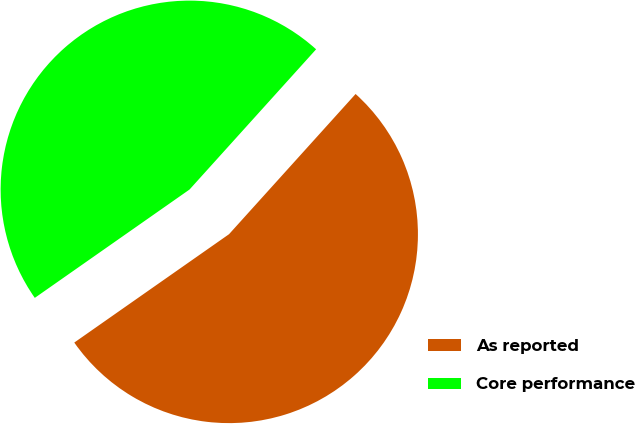<chart> <loc_0><loc_0><loc_500><loc_500><pie_chart><fcel>As reported<fcel>Core performance<nl><fcel>53.59%<fcel>46.41%<nl></chart> 